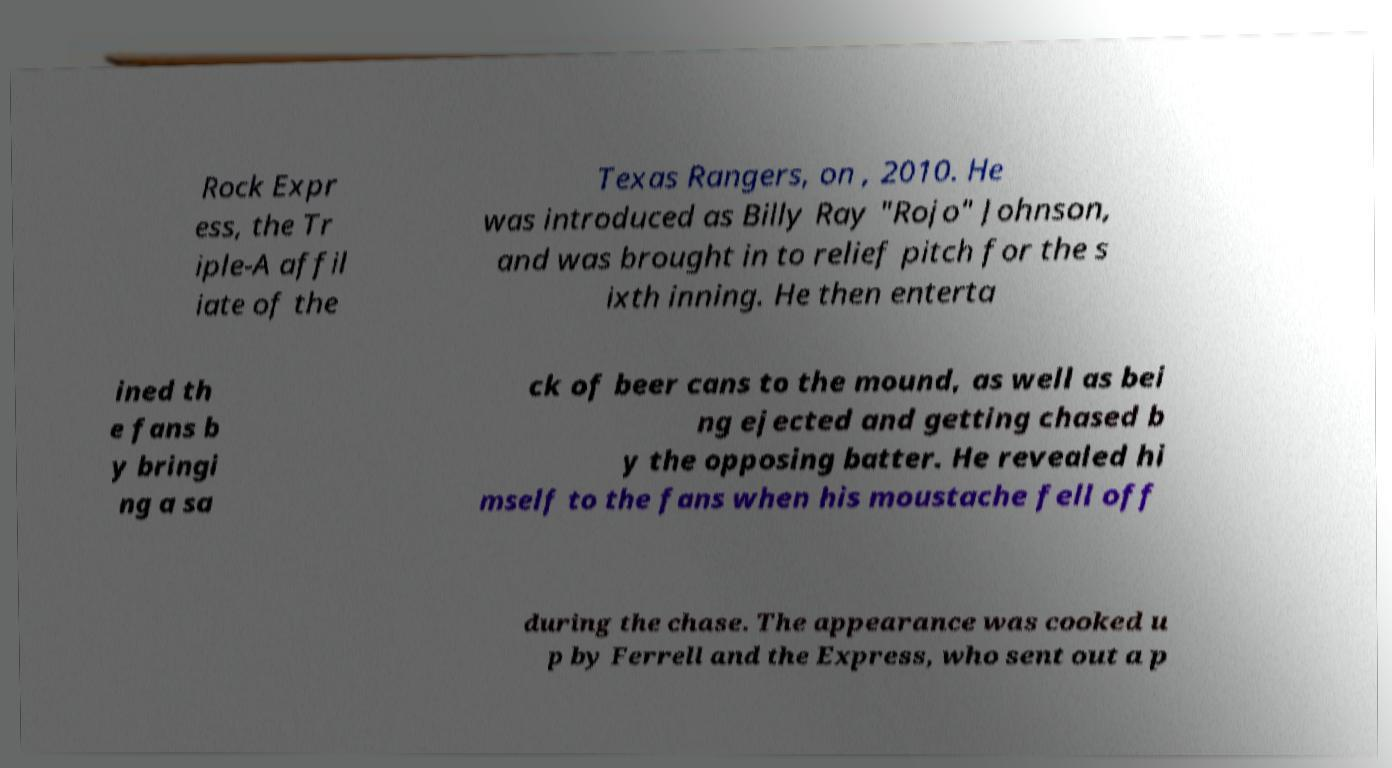Please read and relay the text visible in this image. What does it say? Rock Expr ess, the Tr iple-A affil iate of the Texas Rangers, on , 2010. He was introduced as Billy Ray "Rojo" Johnson, and was brought in to relief pitch for the s ixth inning. He then enterta ined th e fans b y bringi ng a sa ck of beer cans to the mound, as well as bei ng ejected and getting chased b y the opposing batter. He revealed hi mself to the fans when his moustache fell off during the chase. The appearance was cooked u p by Ferrell and the Express, who sent out a p 